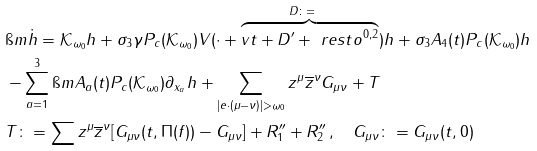Convert formula to latex. <formula><loc_0><loc_0><loc_500><loc_500>& \i m \dot { h } = \mathcal { K } _ { \omega _ { 0 } } h + \sigma _ { 3 } \gamma P _ { c } ( \mathcal { K } _ { \omega _ { 0 } } ) V ( \cdot + \overbrace { v t + D ^ { \prime } + \ r e s t o ^ { 0 , 2 } } ^ { D \colon = \quad } ) h + \sigma _ { 3 } A _ { 4 } ( t ) P _ { c } ( \mathcal { K } _ { \omega _ { 0 } } ) h \\ & - \sum _ { a = 1 } ^ { 3 } \i m A _ { a } ( t ) P _ { c } ( \mathcal { K } _ { \omega _ { 0 } } ) \partial _ { x _ { a } } h + \sum _ { | e \cdot ( \mu - \nu ) | > \omega _ { 0 } } z ^ { \mu } \overline { z } ^ { \nu } G _ { \mu \nu } + T \\ & T \colon = \sum z ^ { \mu } \overline { z } ^ { \nu } [ G _ { \mu \nu } ( t , \Pi ( f ) ) - G _ { \mu \nu } ] + R _ { 1 } ^ { \prime \prime } + R _ { 2 } ^ { \prime \prime } \, , \quad G _ { \mu \nu } \colon = G _ { \mu \nu } ( t , 0 )</formula> 